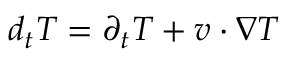<formula> <loc_0><loc_0><loc_500><loc_500>\begin{array} { r } { d _ { t } T = \partial _ { t } T + v \cdot \nabla T } \end{array}</formula> 